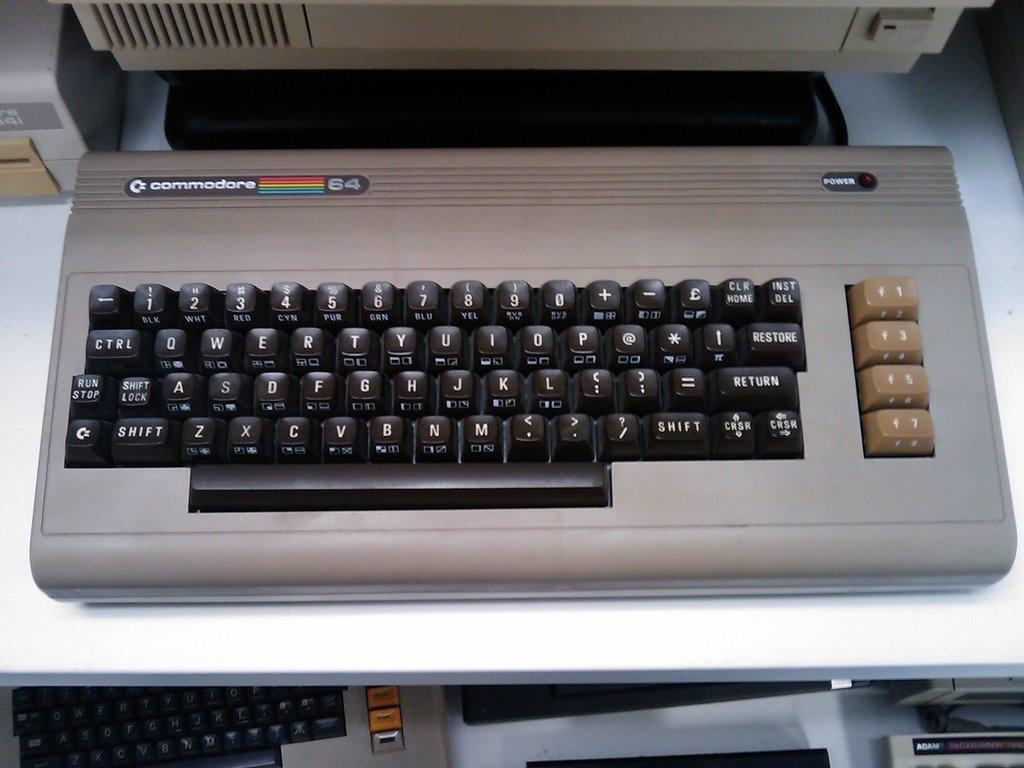Provide a one-sentence caption for the provided image. A Commodore computer keyboard with black with four function keys in tan on the side. 